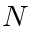Convert formula to latex. <formula><loc_0><loc_0><loc_500><loc_500>N</formula> 